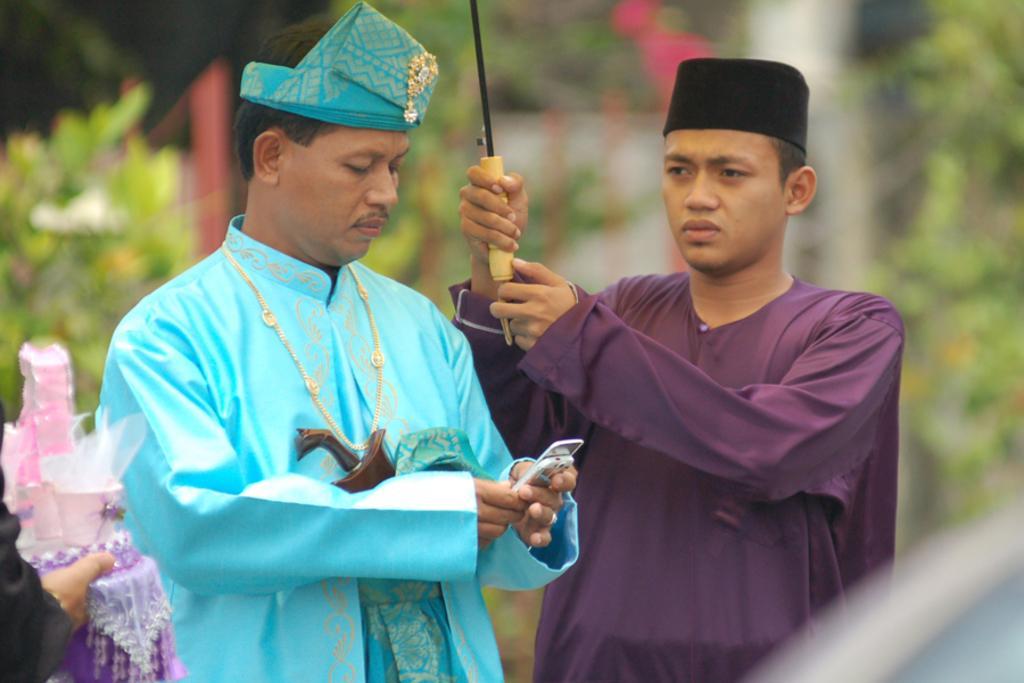Can you describe this image briefly? In this image I can see a two person standing and holding something. They are wearing blue and purple color dress. Back Side I can see trees. It is blurred. 